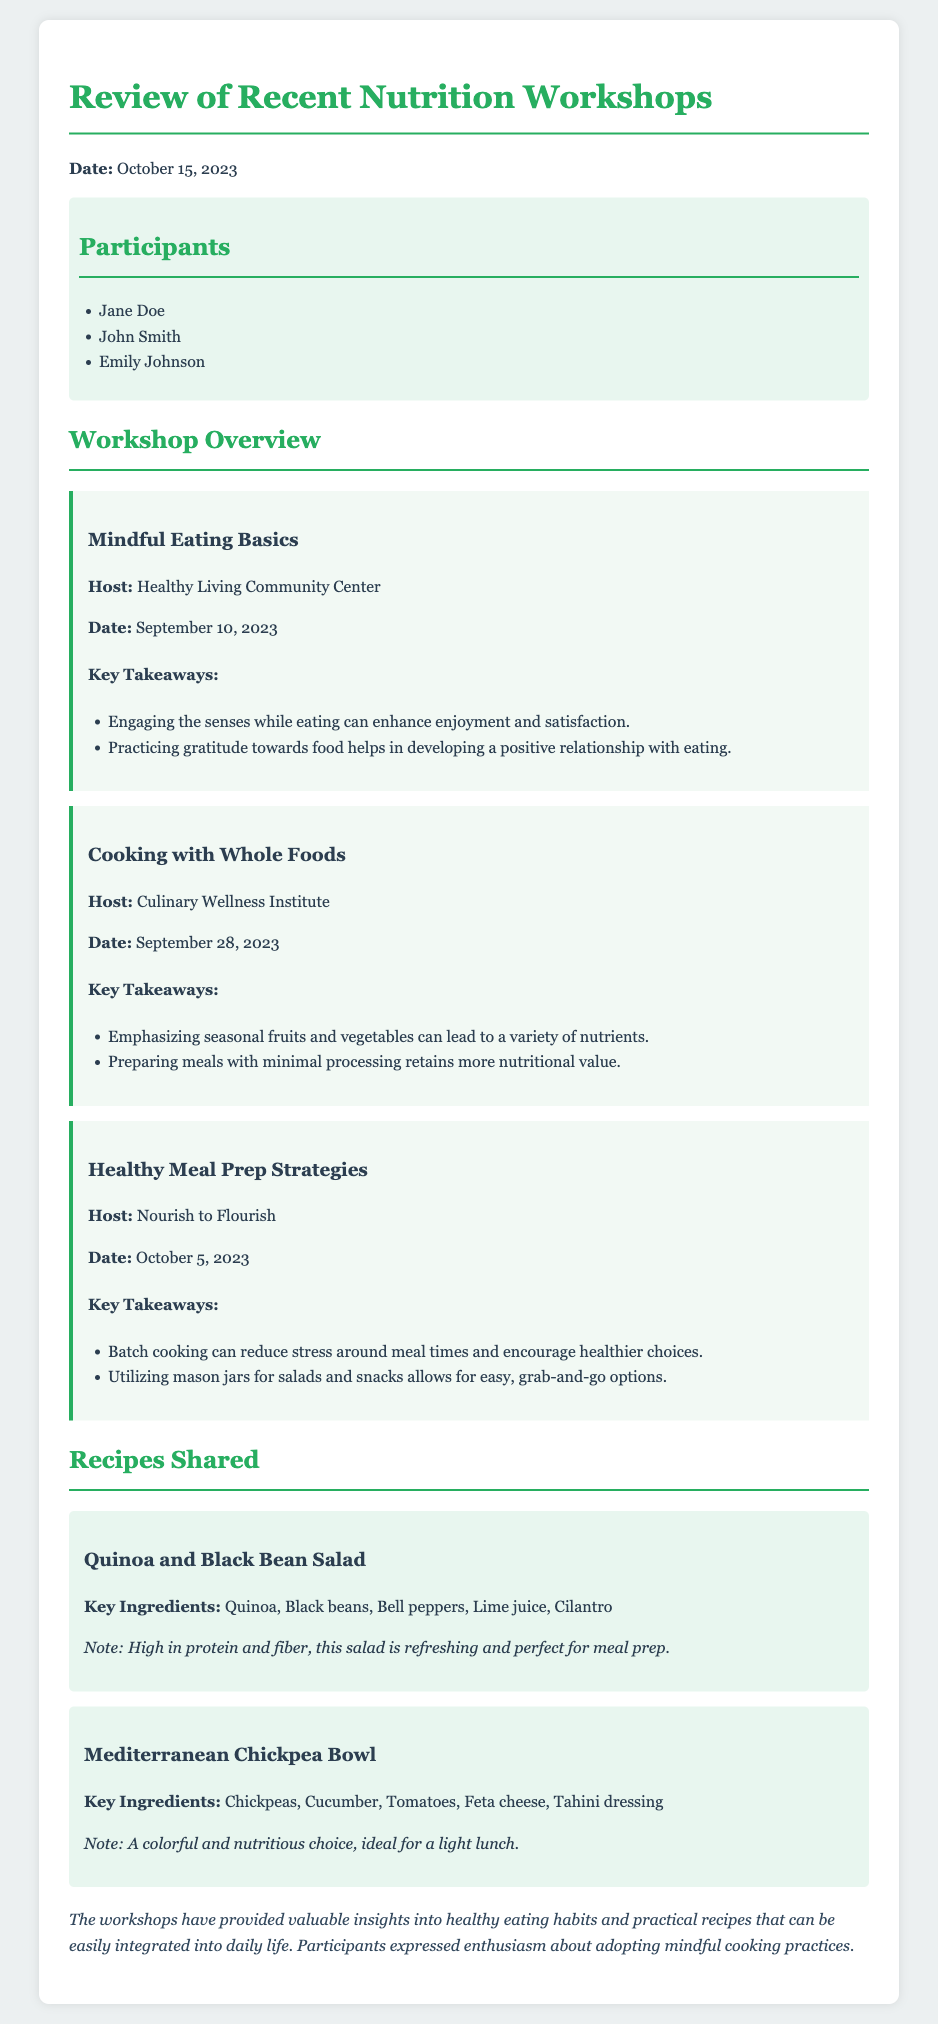What date were the workshops reviewed? The workshops were reviewed on October 15, 2023.
Answer: October 15, 2023 Who hosted the "Mindful Eating Basics" workshop? The "Mindful Eating Basics" workshop was hosted by Healthy Living Community Center.
Answer: Healthy Living Community Center What key ingredient is used in the "Mediterranean Chickpea Bowl"? The "Mediterranean Chickpea Bowl" includes chickpeas as a key ingredient.
Answer: Chickpeas How many workshops are discussed in the document? The document discusses three workshops in total.
Answer: Three What was a major takeaway from the "Cooking with Whole Foods" workshop? A major takeaway was that preparing meals with minimal processing retains more nutritional value.
Answer: Minimal processing retains more nutritional value Which recipe is noted for being high in protein and fiber? The "Quinoa and Black Bean Salad" is noted for being high in protein and fiber.
Answer: Quinoa and Black Bean Salad What theme is common among the key takeaways from all workshops? They all promote healthier eating habits and mindfulness around food.
Answer: Healthier eating habits and mindfulness What method is suggested for easy meal prep in the "Healthy Meal Prep Strategies" workshop? Utilizing mason jars for salads and snacks is suggested for easy meal prep.
Answer: Mason jars for salads and snacks 